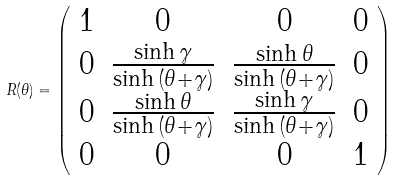Convert formula to latex. <formula><loc_0><loc_0><loc_500><loc_500>R ( \theta ) = \left ( \begin{array} { c c c c } 1 & 0 & 0 & 0 \\ 0 & \frac { \sinh { \gamma } } { \sinh { ( \theta + \gamma ) } } & \frac { \sinh { \theta } } { \sinh { ( \theta + \gamma ) } } & 0 \\ 0 & \frac { \sinh { \theta } } { \sinh { ( \theta + \gamma ) } } & \frac { \sinh { \gamma } } { \sinh { ( \theta + \gamma ) } } & 0 \\ 0 & 0 & 0 & 1 \end{array} \right )</formula> 